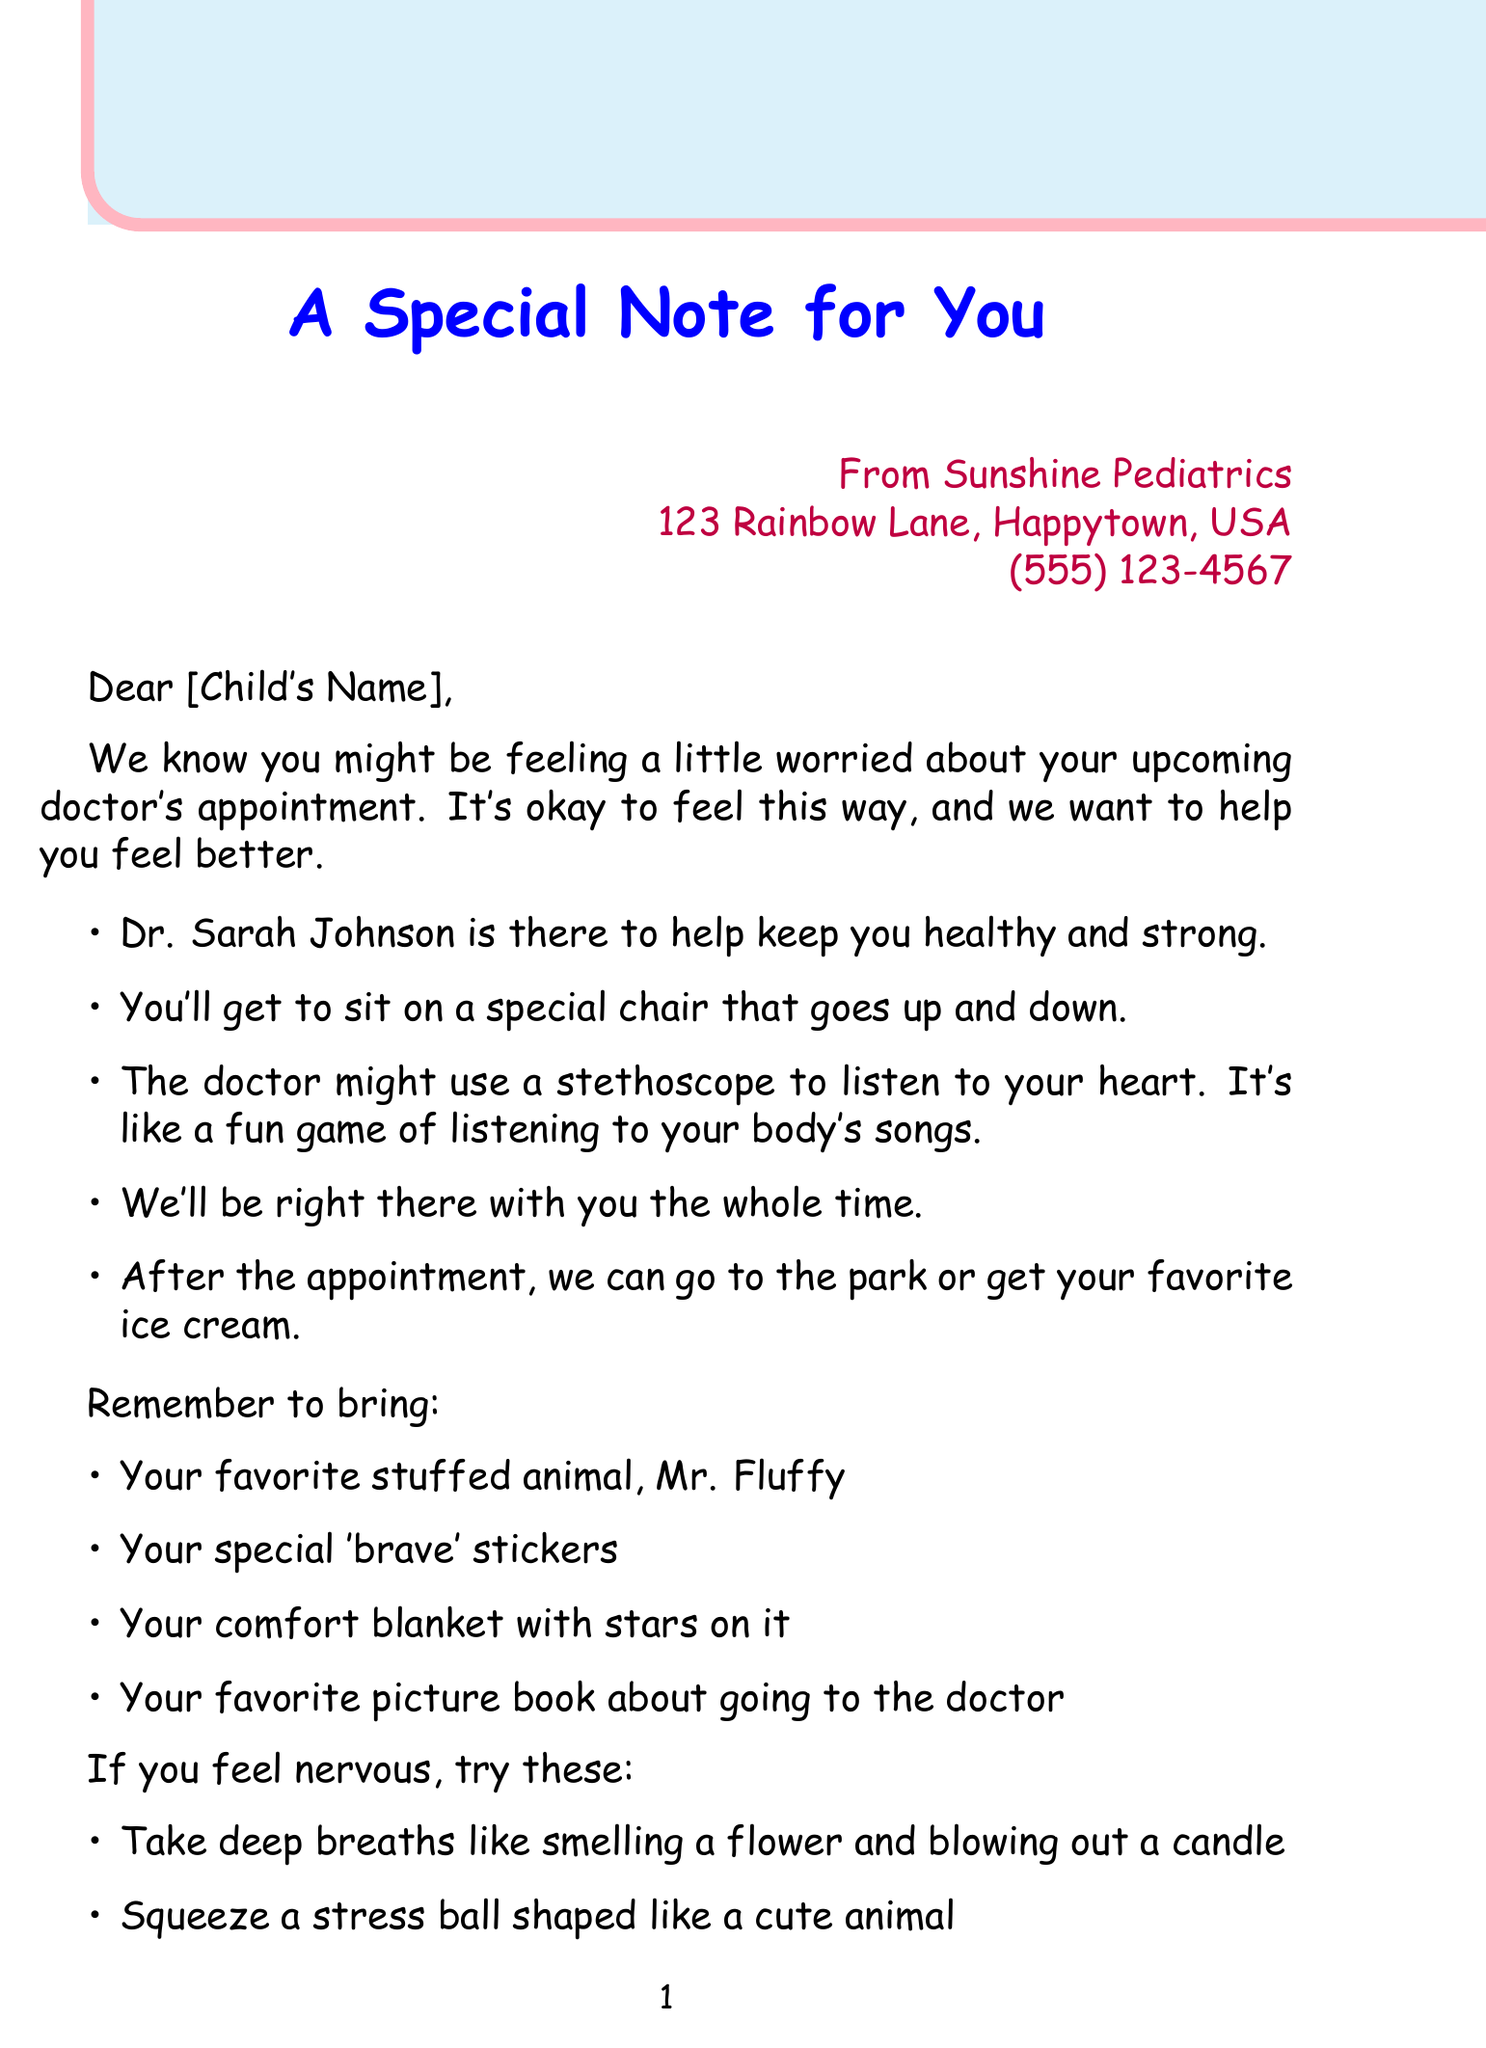what is the doctor's name? The doctor's name is mentioned in the letter.
Answer: Dr. Sarah Johnson what is the address of the office? The address of the office is provided in the letter.
Answer: 123 Rainbow Lane, Happytown, USA what can you bring for comfort? The letter lists comfort items that can be brought.
Answer: Mr. Fluffy what is the first relaxation technique mentioned? The letter provides a list of relaxation techniques.
Answer: Taking deep breaths what activity is planned after the appointment? The letter mentions plans after the appointment.
Answer: Go to the park what does the doctor use to listen to your heart? This is described in the main content of the letter.
Answer: Stethoscope how are the parents described in the closing? The closing part of the letter emphasizes the parents' feelings.
Answer: Brave little superhero how many post-appointment rewards are listed? Counting the items in the post-appointment rewards section.
Answer: Four 